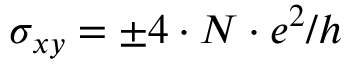<formula> <loc_0><loc_0><loc_500><loc_500>\sigma _ { x y } = \pm { 4 \cdot N \cdot e ^ { 2 } } / h</formula> 